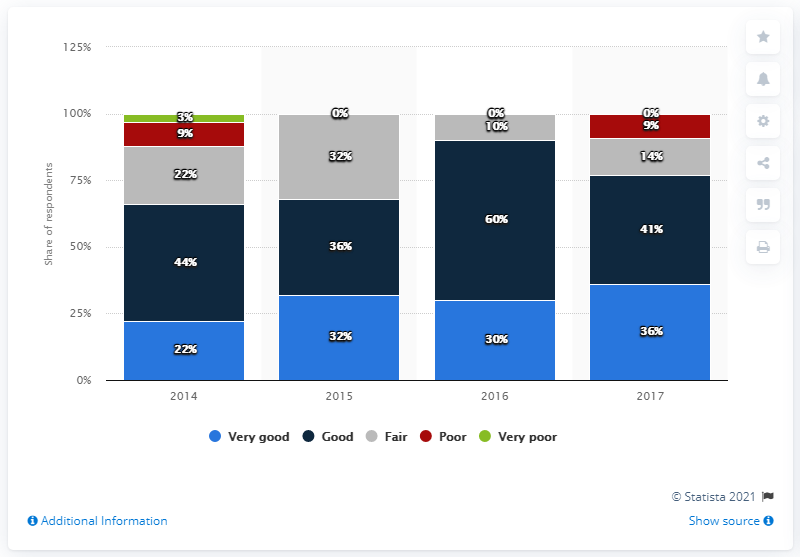List a handful of essential elements in this visual. In 2016, the prospects for investment in retirement properties improved significantly. 